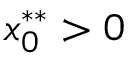<formula> <loc_0><loc_0><loc_500><loc_500>x _ { 0 } ^ { * * } > 0</formula> 